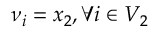Convert formula to latex. <formula><loc_0><loc_0><loc_500><loc_500>\nu _ { i } = x _ { 2 } , \forall i \in V _ { 2 }</formula> 